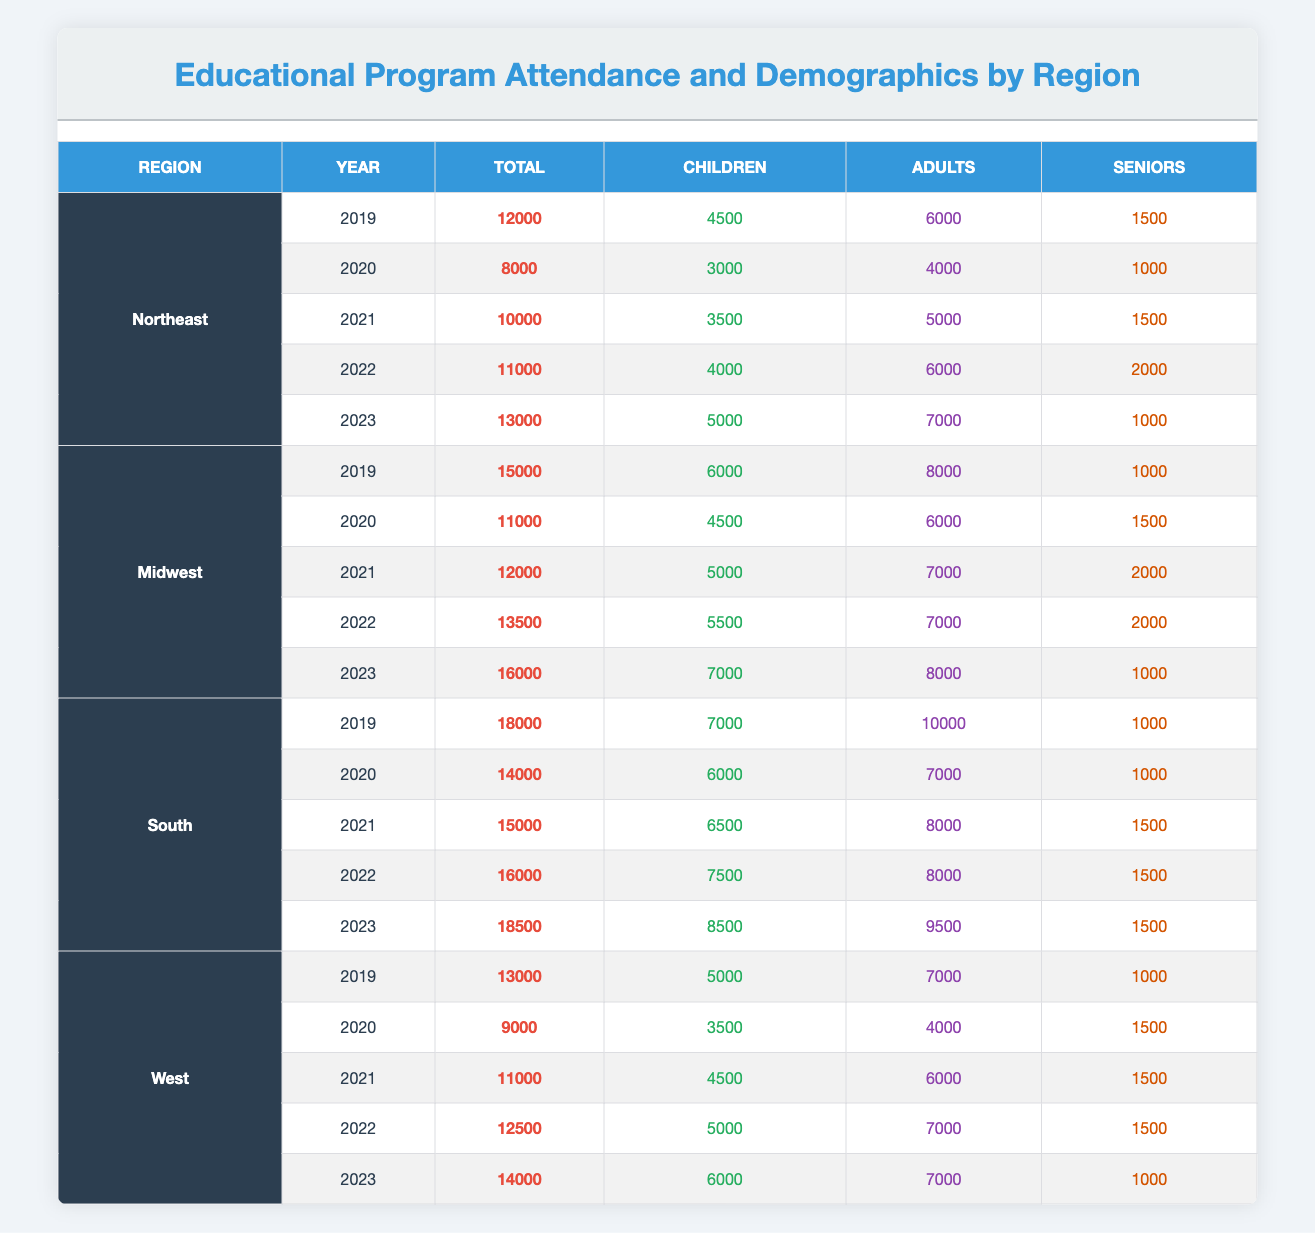What was the total attendance in the South region in 2022? The table indicates that the South region had a total attendance of 16000 in 2022.
Answer: 16000 Which region had the highest number of child attendees in 2023? In 2023, the South region had 8500 child attendees, compared to 7000 in the Midwest and Northeast and 6000 in the West. Therefore, the South region had the highest number of child attendees.
Answer: South What is the total attendance across all regions in 2021? To find the total attendance in 2021, we sum the attendance from all regions: Northeast (10000) + Midwest (12000) + South (15000) + West (11000) = 48000.
Answer: 48000 Is the total attendance in the Midwest region increasing every year from 2019 to 2023? By comparing the attendance for each year: 2019 (15000), 2020 (11000), 2021 (12000), 2022 (13500), and 2023 (16000), it can be seen that it decreased in 2020 but increased in subsequent years. Therefore, the statement is false.
Answer: No What was the average number of senior attendees in the Northeast region over the five years? Summing the number of senior attendees in the Northeast region from 2019 to 2023 gives us 1500 + 1000 + 1500 + 2000 + 1000 = 8000. Dividing that by 5 years, we find the average is 8000 / 5 = 1600.
Answer: 1600 Which year saw the lowest total attendance in the West region? Looking at the West region attendance values: 2019 (13000), 2020 (9000), 2021 (11000), 2022 (12500), and 2023 (14000), the lowest total attendance was in 2020 with 9000.
Answer: 2020 Did the number of adult attendees in the South region surpass the number of children in any year from 2019 to 2023? Checking the values for adult and child attendees in the South region: 2019 (Adults: 10000, Children: 7000), 2020 (7000, 6000), 2021 (8000, 6500), 2022 (8000, 7500), and 2023 (9500, 8500). In all years, adult attendees were higher than child attendees. Therefore, the answer is yes.
Answer: Yes What is the total increase in attendance from 2019 to 2023 in the Northeast region? The total attendance in 2019 was 12000 and in 2023 it was 13000. The increase is calculated by subtracting: 13000 - 12000 = 1000.
Answer: 1000 Which region had the least attendance in 2020? The attendance values for 2020 are: Northeast (8000), Midwest (11000), South (14000), and West (9000). The Northeast had the lowest attendance at 8000.
Answer: Northeast 